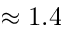<formula> <loc_0><loc_0><loc_500><loc_500>\approx 1 . 4</formula> 